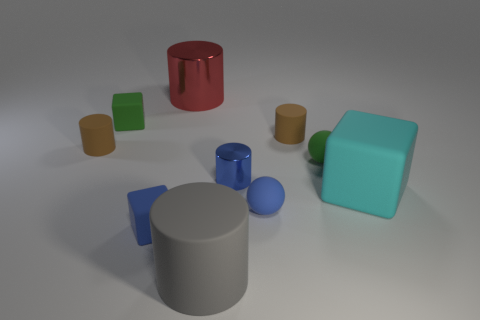Do the red cylinder and the gray object have the same size?
Make the answer very short. Yes. There is a small brown rubber cylinder in front of the brown matte cylinder that is to the right of the big shiny cylinder; are there any green matte balls that are behind it?
Your answer should be very brief. No. The blue metal cylinder is what size?
Provide a succinct answer. Small. How many blue rubber objects are the same size as the blue rubber cube?
Your answer should be compact. 1. There is a large gray object that is the same shape as the red shiny object; what is it made of?
Offer a terse response. Rubber. What shape is the large thing that is both to the left of the big cyan matte thing and behind the small blue block?
Offer a terse response. Cylinder. What is the shape of the large shiny thing on the left side of the big matte cube?
Provide a short and direct response. Cylinder. How many things are in front of the tiny blue cube and right of the gray rubber thing?
Give a very brief answer. 0. Does the gray object have the same size as the green thing that is on the left side of the gray thing?
Provide a succinct answer. No. There is a green object that is to the right of the tiny green rubber thing that is on the left side of the large cylinder that is right of the big red cylinder; what size is it?
Offer a very short reply. Small. 